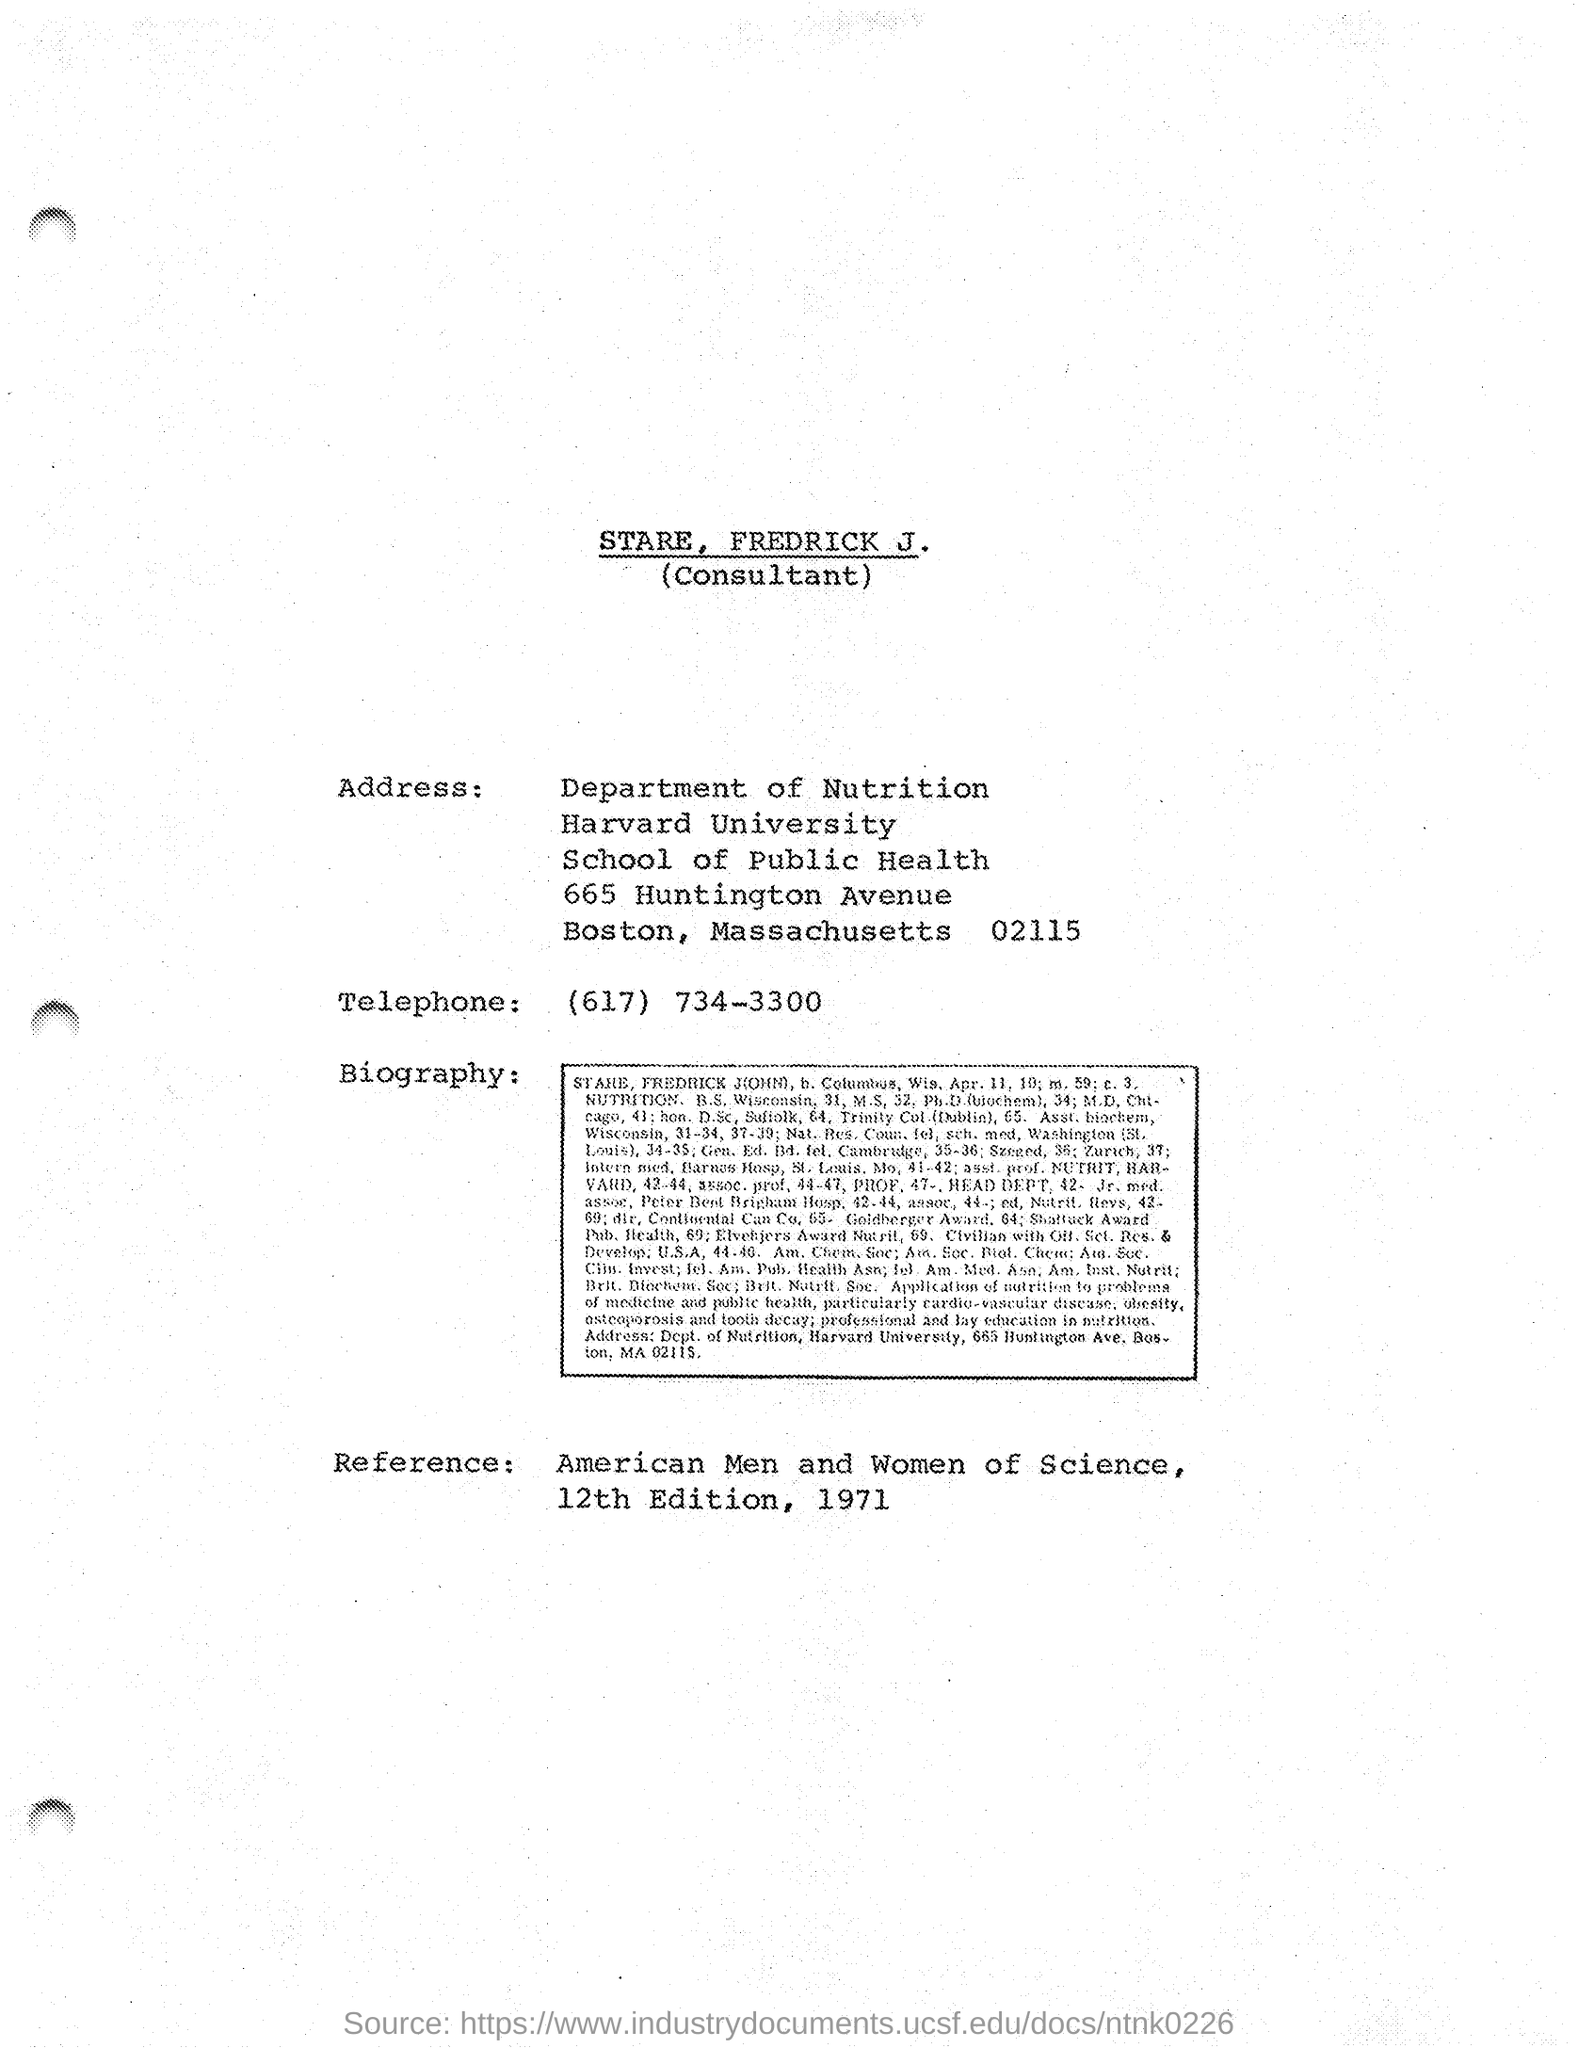Give some essential details in this illustration. Stare belongs to the Department of Nutrition. 